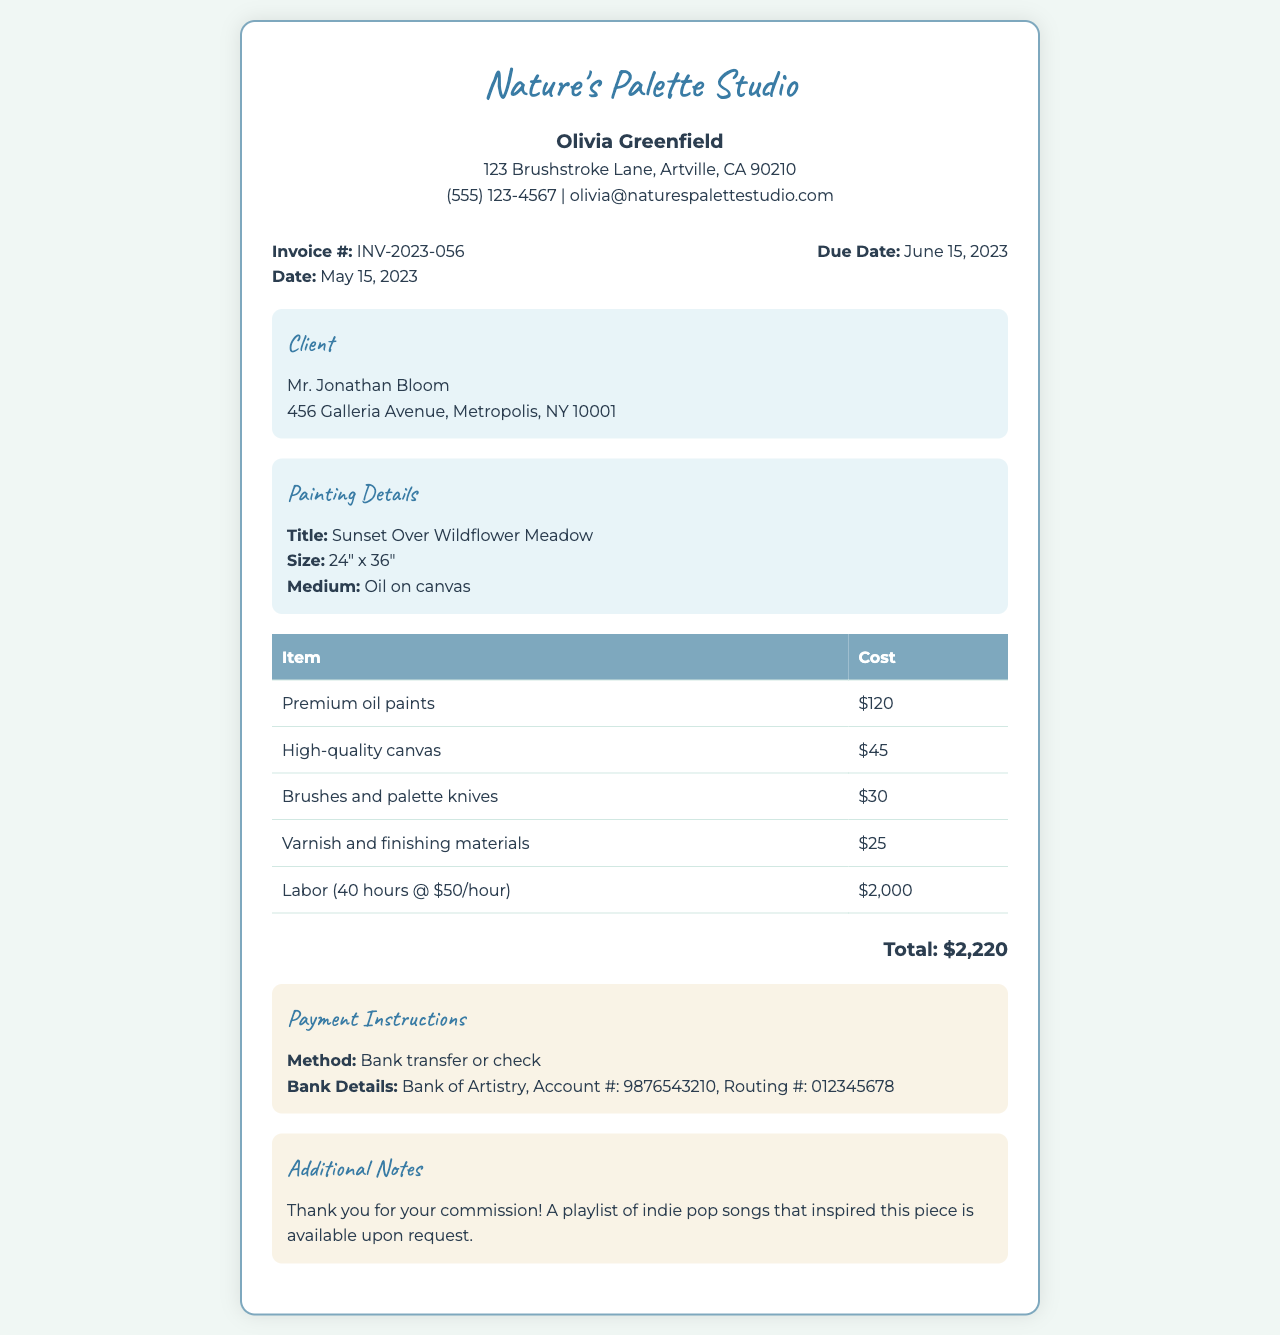What is the invoice number? The invoice number is clearly listed in the document as INV-2023-056.
Answer: INV-2023-056 Who is the artist? The artist's name is mentioned at the top of the document as Olivia Greenfield.
Answer: Olivia Greenfield What is the title of the painting? The title of the painting is specified in the painting details section as Sunset Over Wildflower Meadow.
Answer: Sunset Over Wildflower Meadow What is the total cost? The total cost of the invoice is summarized at the bottom as $2,220.
Answer: $2,220 How many hours of labor were included? The breakdown states 40 hours of labor were charged for the painting.
Answer: 40 hours What method of payment is accepted? The payment instructions indicate that bank transfer or check is accepted.
Answer: Bank transfer or check What are the client's details? The client's information is listed, including the name Jonathan Bloom and the address, which is part of the client info section.
Answer: Mr. Jonathan Bloom, 456 Galleria Avenue, Metropolis, NY 10001 What is included in the additional notes? The additional notes section contains a thank you message and mentions a playlist of indie pop songs available upon request.
Answer: Thank you for your commission! A playlist of indie pop songs that inspired this piece is available upon request What was the medium of the painting? The medium of the painting is specified in the painting details as Oil on canvas.
Answer: Oil on canvas 